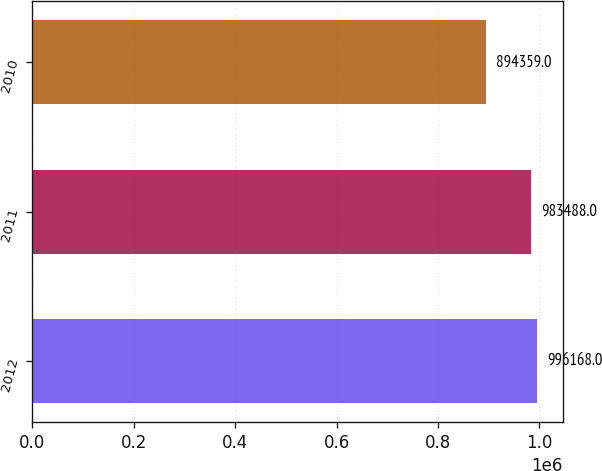Convert chart. <chart><loc_0><loc_0><loc_500><loc_500><bar_chart><fcel>2012<fcel>2011<fcel>2010<nl><fcel>996168<fcel>983488<fcel>894359<nl></chart> 